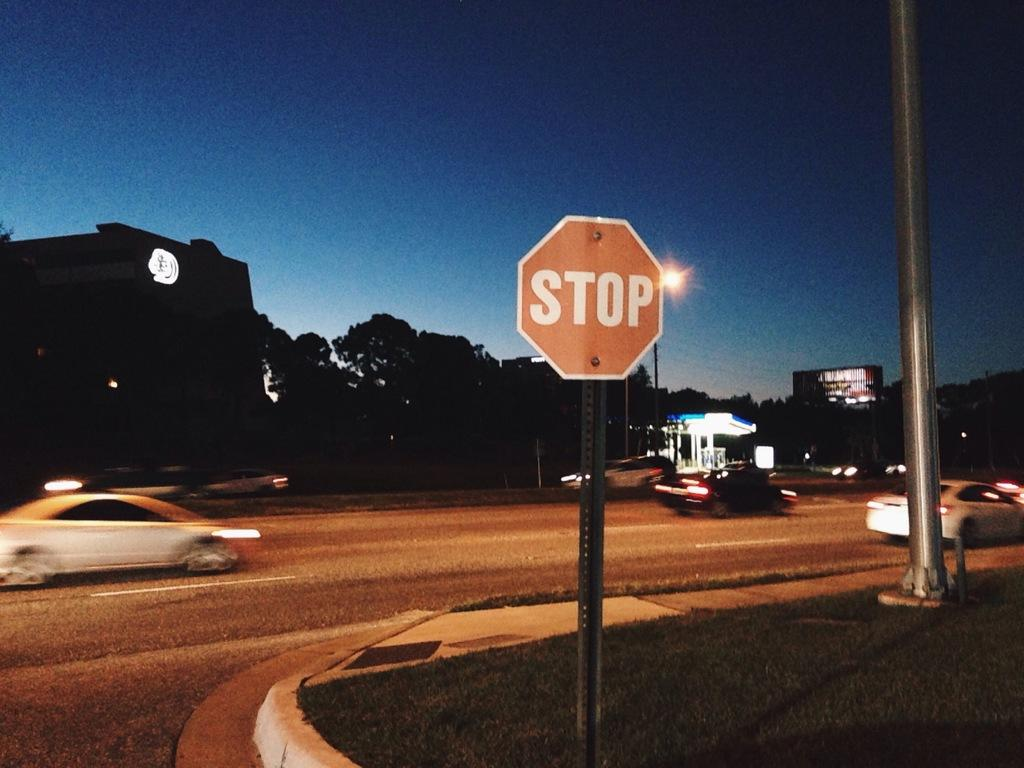<image>
Describe the image concisely. A stop sign is in the grass next to end of the road. 